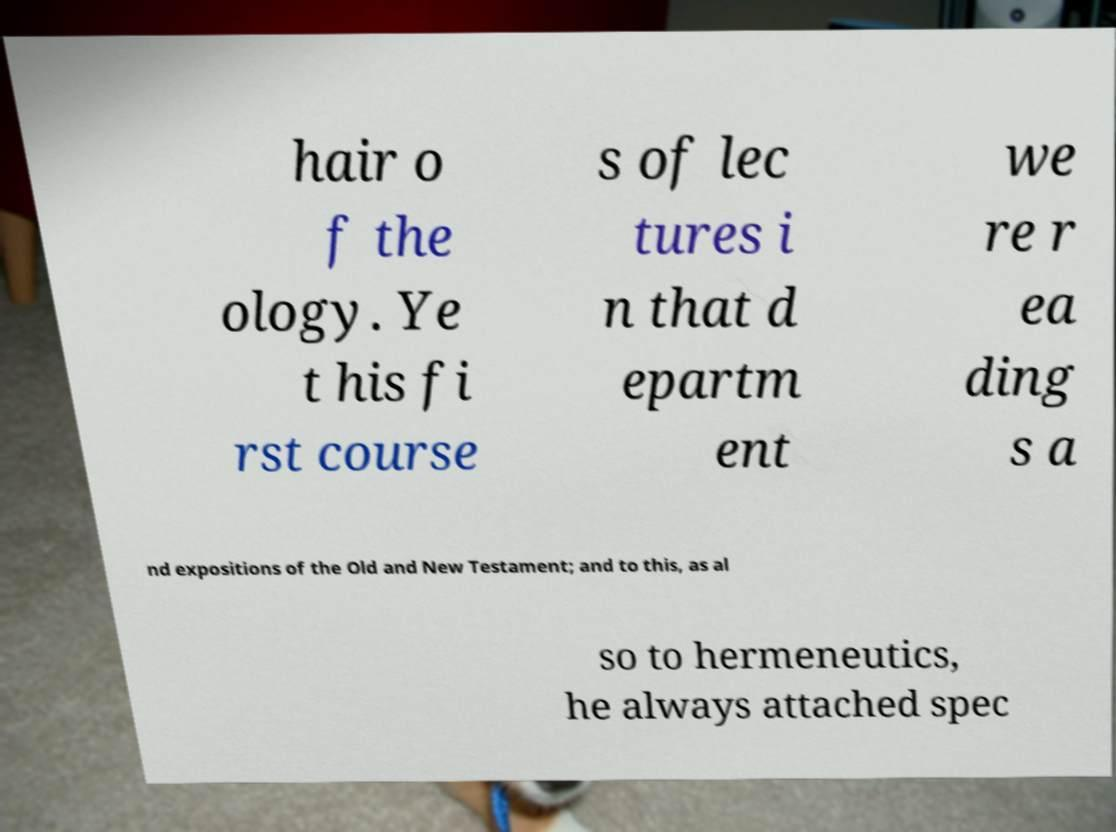There's text embedded in this image that I need extracted. Can you transcribe it verbatim? hair o f the ology. Ye t his fi rst course s of lec tures i n that d epartm ent we re r ea ding s a nd expositions of the Old and New Testament; and to this, as al so to hermeneutics, he always attached spec 